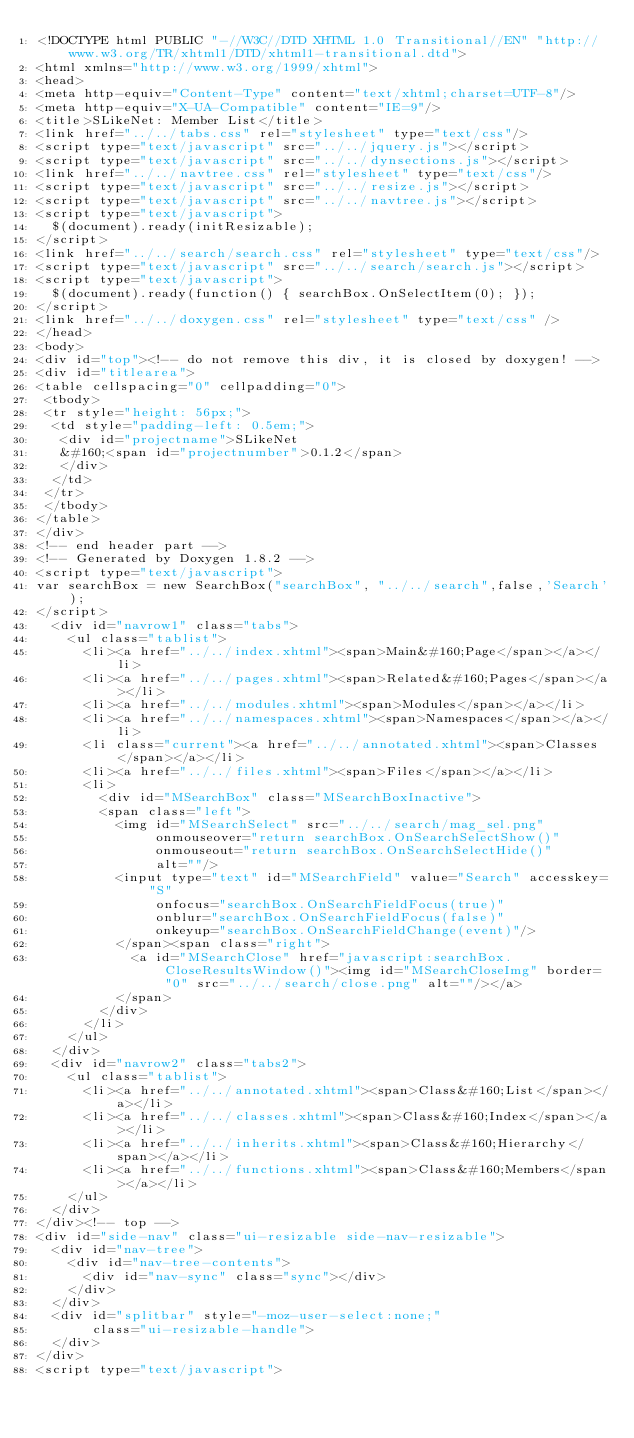<code> <loc_0><loc_0><loc_500><loc_500><_HTML_><!DOCTYPE html PUBLIC "-//W3C//DTD XHTML 1.0 Transitional//EN" "http://www.w3.org/TR/xhtml1/DTD/xhtml1-transitional.dtd">
<html xmlns="http://www.w3.org/1999/xhtml">
<head>
<meta http-equiv="Content-Type" content="text/xhtml;charset=UTF-8"/>
<meta http-equiv="X-UA-Compatible" content="IE=9"/>
<title>SLikeNet: Member List</title>
<link href="../../tabs.css" rel="stylesheet" type="text/css"/>
<script type="text/javascript" src="../../jquery.js"></script>
<script type="text/javascript" src="../../dynsections.js"></script>
<link href="../../navtree.css" rel="stylesheet" type="text/css"/>
<script type="text/javascript" src="../../resize.js"></script>
<script type="text/javascript" src="../../navtree.js"></script>
<script type="text/javascript">
  $(document).ready(initResizable);
</script>
<link href="../../search/search.css" rel="stylesheet" type="text/css"/>
<script type="text/javascript" src="../../search/search.js"></script>
<script type="text/javascript">
  $(document).ready(function() { searchBox.OnSelectItem(0); });
</script>
<link href="../../doxygen.css" rel="stylesheet" type="text/css" />
</head>
<body>
<div id="top"><!-- do not remove this div, it is closed by doxygen! -->
<div id="titlearea">
<table cellspacing="0" cellpadding="0">
 <tbody>
 <tr style="height: 56px;">
  <td style="padding-left: 0.5em;">
   <div id="projectname">SLikeNet
   &#160;<span id="projectnumber">0.1.2</span>
   </div>
  </td>
 </tr>
 </tbody>
</table>
</div>
<!-- end header part -->
<!-- Generated by Doxygen 1.8.2 -->
<script type="text/javascript">
var searchBox = new SearchBox("searchBox", "../../search",false,'Search');
</script>
  <div id="navrow1" class="tabs">
    <ul class="tablist">
      <li><a href="../../index.xhtml"><span>Main&#160;Page</span></a></li>
      <li><a href="../../pages.xhtml"><span>Related&#160;Pages</span></a></li>
      <li><a href="../../modules.xhtml"><span>Modules</span></a></li>
      <li><a href="../../namespaces.xhtml"><span>Namespaces</span></a></li>
      <li class="current"><a href="../../annotated.xhtml"><span>Classes</span></a></li>
      <li><a href="../../files.xhtml"><span>Files</span></a></li>
      <li>
        <div id="MSearchBox" class="MSearchBoxInactive">
        <span class="left">
          <img id="MSearchSelect" src="../../search/mag_sel.png"
               onmouseover="return searchBox.OnSearchSelectShow()"
               onmouseout="return searchBox.OnSearchSelectHide()"
               alt=""/>
          <input type="text" id="MSearchField" value="Search" accesskey="S"
               onfocus="searchBox.OnSearchFieldFocus(true)" 
               onblur="searchBox.OnSearchFieldFocus(false)" 
               onkeyup="searchBox.OnSearchFieldChange(event)"/>
          </span><span class="right">
            <a id="MSearchClose" href="javascript:searchBox.CloseResultsWindow()"><img id="MSearchCloseImg" border="0" src="../../search/close.png" alt=""/></a>
          </span>
        </div>
      </li>
    </ul>
  </div>
  <div id="navrow2" class="tabs2">
    <ul class="tablist">
      <li><a href="../../annotated.xhtml"><span>Class&#160;List</span></a></li>
      <li><a href="../../classes.xhtml"><span>Class&#160;Index</span></a></li>
      <li><a href="../../inherits.xhtml"><span>Class&#160;Hierarchy</span></a></li>
      <li><a href="../../functions.xhtml"><span>Class&#160;Members</span></a></li>
    </ul>
  </div>
</div><!-- top -->
<div id="side-nav" class="ui-resizable side-nav-resizable">
  <div id="nav-tree">
    <div id="nav-tree-contents">
      <div id="nav-sync" class="sync"></div>
    </div>
  </div>
  <div id="splitbar" style="-moz-user-select:none;" 
       class="ui-resizable-handle">
  </div>
</div>
<script type="text/javascript"></code> 